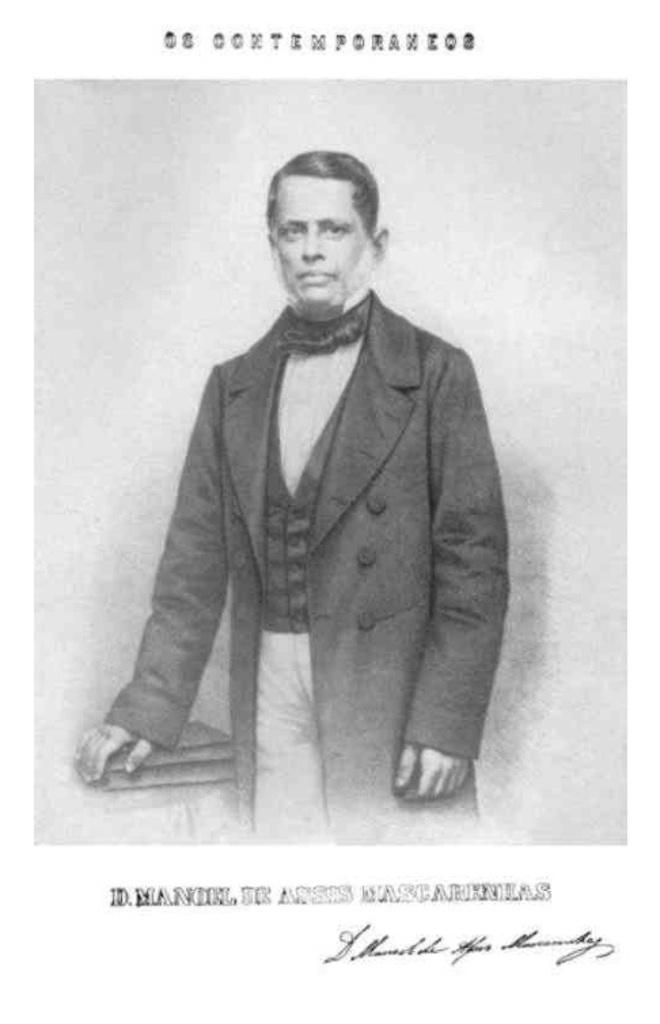Who is the main subject in the image? There is a man in the middle of the image. What is the man wearing? The man is wearing a black coat. What can be seen on the left side of the image? There are books on the left side of the image. How many nails are visible in the image? There are no nails present in the image. What type of joke is the man telling in the image? There is no indication of a joke being told in the image; the man is simply standing there wearing a black coat. 